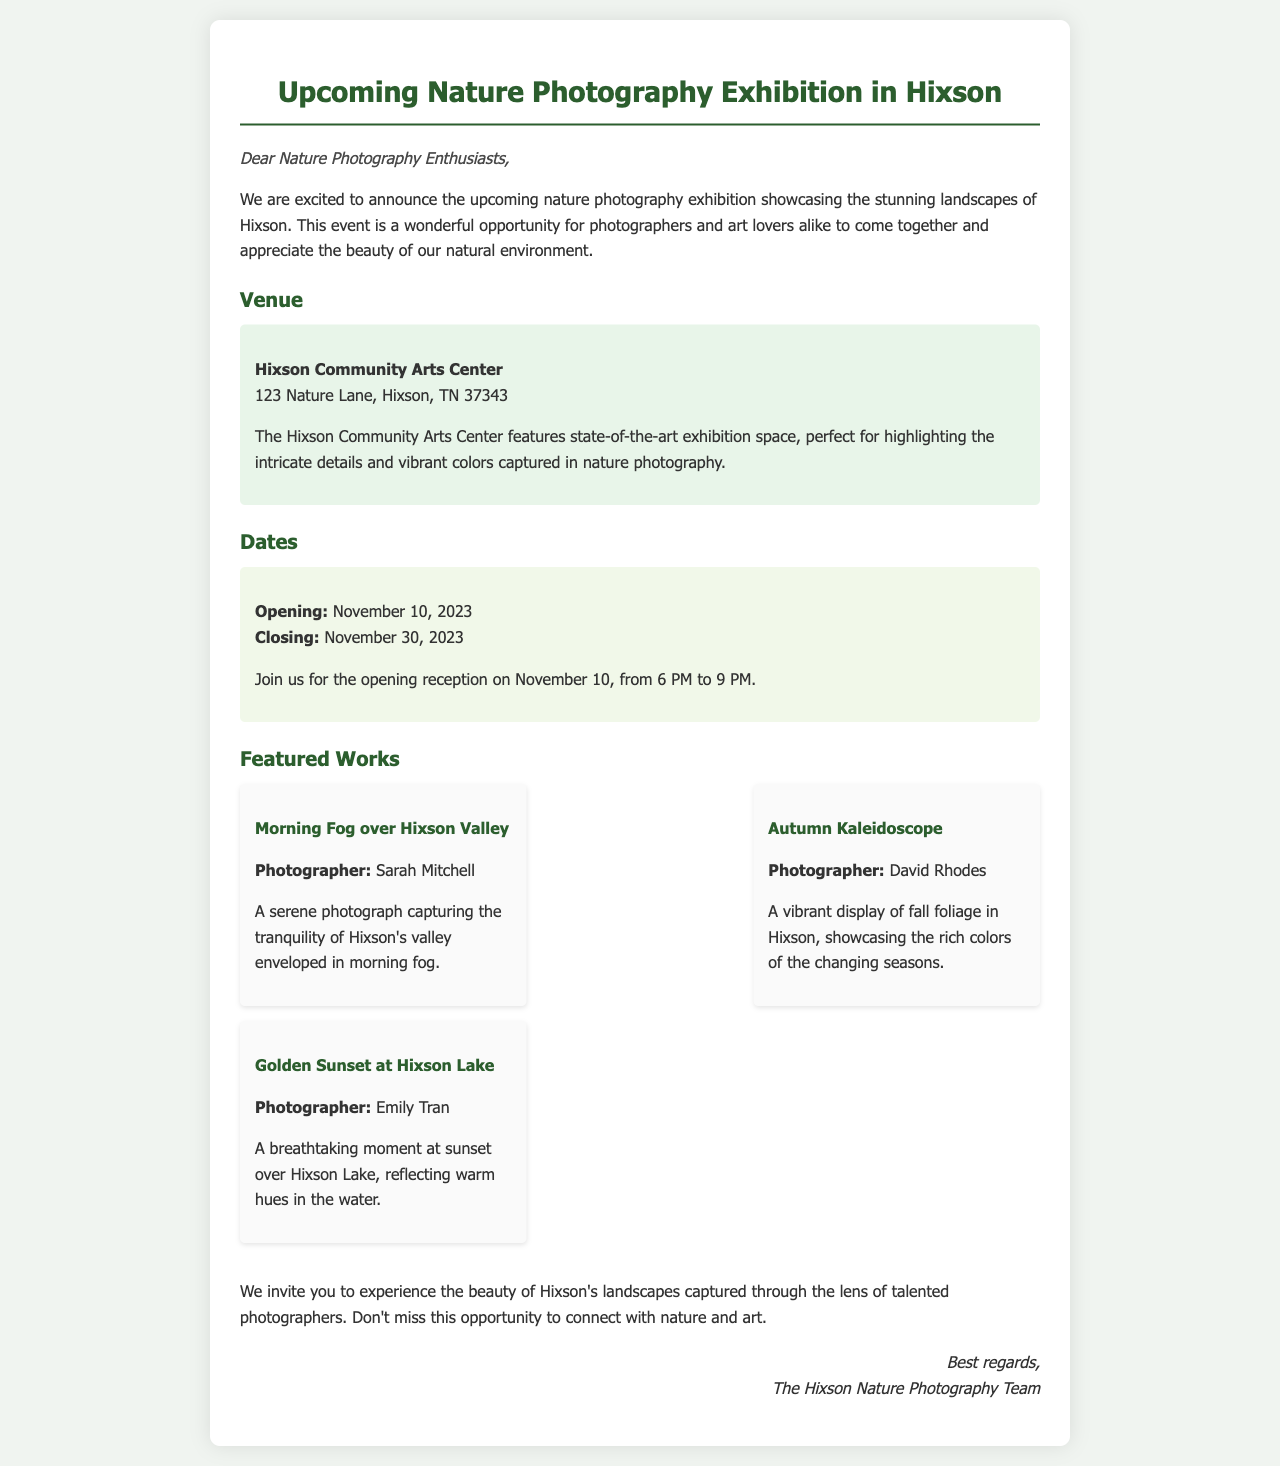What is the venue for the exhibition? The document lists the venue for the exhibition as Hixson Community Arts Center.
Answer: Hixson Community Arts Center When does the exhibition open? The opening date for the exhibition is specifically mentioned in the document.
Answer: November 10, 2023 Who is the photographer of "Morning Fog over Hixson Valley"? The document provides the name of the photographer for this specific work.
Answer: Sarah Mitchell What is highlighted about the Hixson Community Arts Center? The document provides a description of the features of the venue, specifically its suitability for photography.
Answer: State-of-the-art exhibition space How long does the exhibition last? The closing date is needed in conjunction with the opening date to determine the duration of the exhibition.
Answer: 21 days What time is the opening reception? The document specifies the time for the opening event on the opening date.
Answer: 6 PM to 9 PM Who created the "Golden Sunset at Hixson Lake"? This question seeks the name of the photographer responsible for a particular featured work listed in the document.
Answer: Emily Tran What theme is conveyed in "Autumn Kaleidoscope"? The document describes the essence of this specific work, which includes elements of nature.
Answer: Fall foliage 